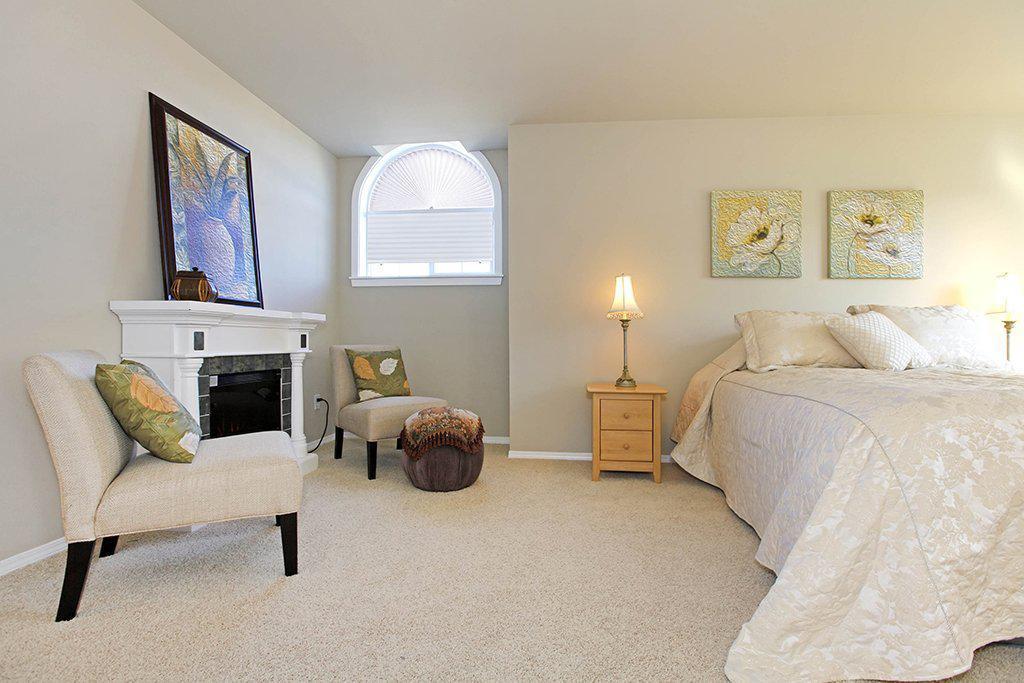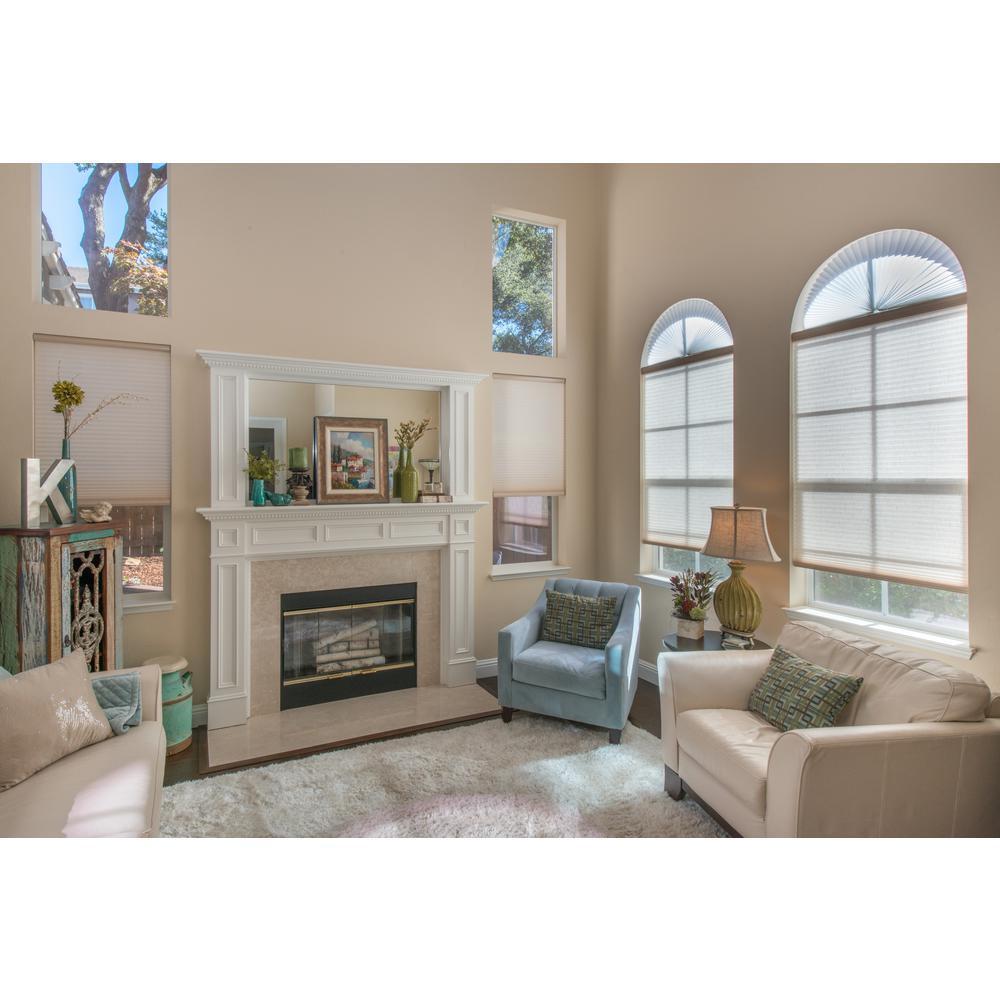The first image is the image on the left, the second image is the image on the right. Analyze the images presented: Is the assertion "There is furniture visible in exactly one image." valid? Answer yes or no. No. The first image is the image on the left, the second image is the image on the right. For the images shown, is this caption "There are only two windows visible." true? Answer yes or no. No. 